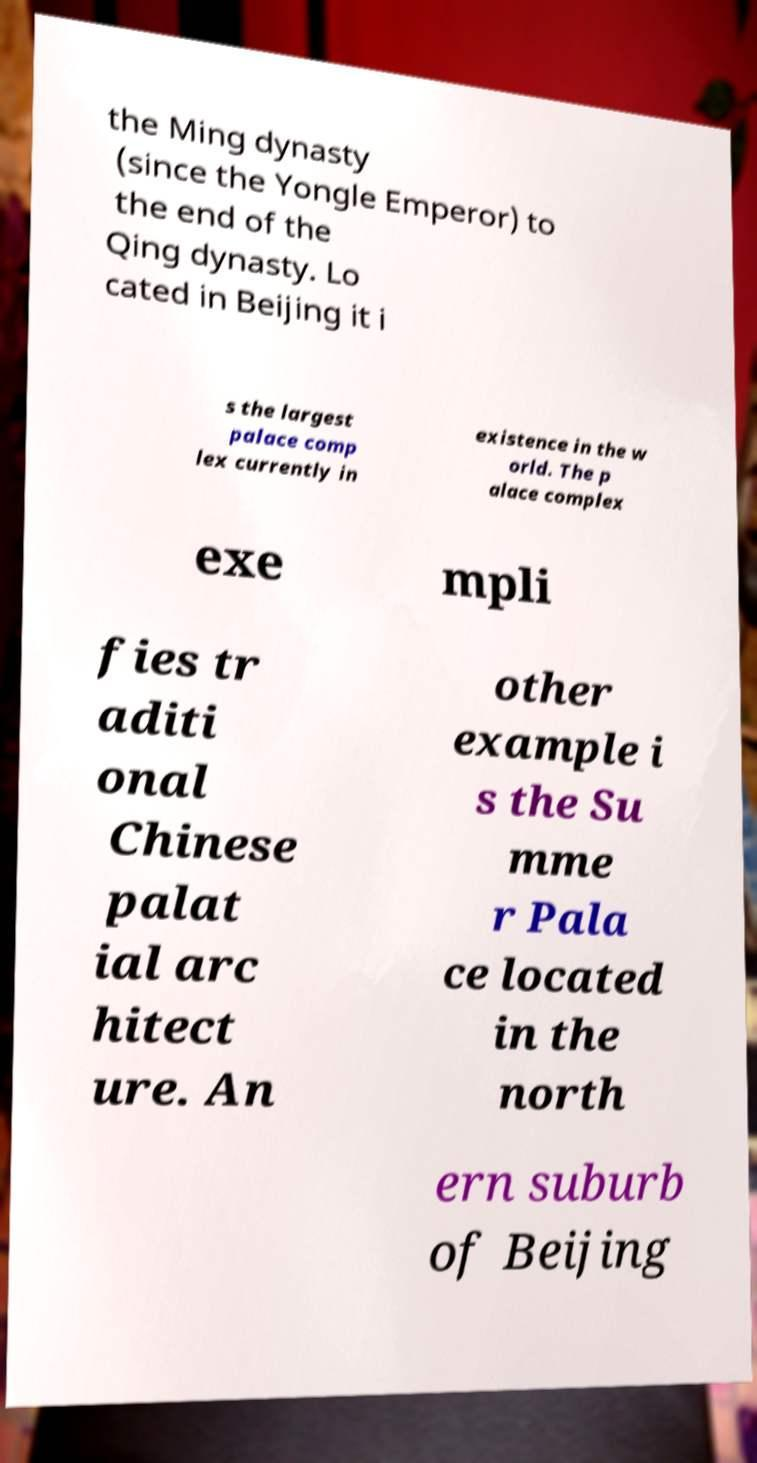Please identify and transcribe the text found in this image. the Ming dynasty (since the Yongle Emperor) to the end of the Qing dynasty. Lo cated in Beijing it i s the largest palace comp lex currently in existence in the w orld. The p alace complex exe mpli fies tr aditi onal Chinese palat ial arc hitect ure. An other example i s the Su mme r Pala ce located in the north ern suburb of Beijing 